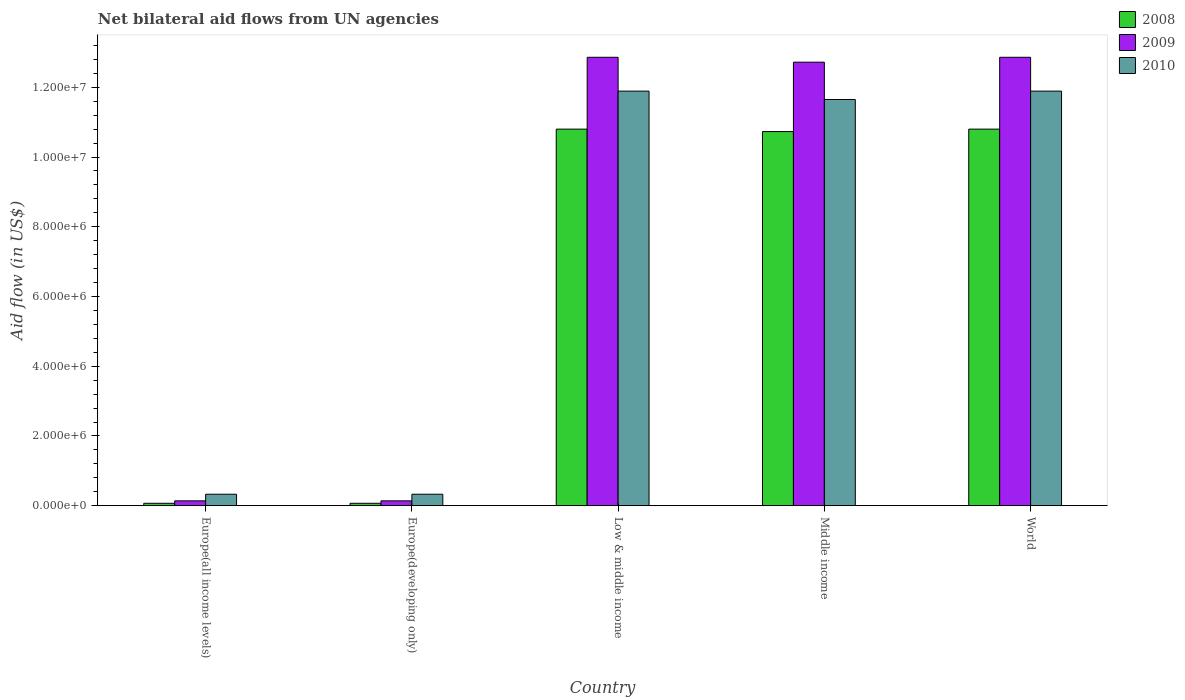How many different coloured bars are there?
Offer a terse response. 3. Are the number of bars per tick equal to the number of legend labels?
Your answer should be very brief. Yes. Are the number of bars on each tick of the X-axis equal?
Provide a short and direct response. Yes. How many bars are there on the 4th tick from the right?
Give a very brief answer. 3. What is the label of the 4th group of bars from the left?
Offer a terse response. Middle income. In how many cases, is the number of bars for a given country not equal to the number of legend labels?
Ensure brevity in your answer.  0. What is the net bilateral aid flow in 2009 in Middle income?
Ensure brevity in your answer.  1.27e+07. Across all countries, what is the maximum net bilateral aid flow in 2008?
Provide a short and direct response. 1.08e+07. Across all countries, what is the minimum net bilateral aid flow in 2008?
Your response must be concise. 7.00e+04. In which country was the net bilateral aid flow in 2008 maximum?
Make the answer very short. Low & middle income. In which country was the net bilateral aid flow in 2009 minimum?
Ensure brevity in your answer.  Europe(all income levels). What is the total net bilateral aid flow in 2009 in the graph?
Ensure brevity in your answer.  3.87e+07. What is the difference between the net bilateral aid flow in 2010 in Europe(all income levels) and that in World?
Provide a succinct answer. -1.16e+07. What is the difference between the net bilateral aid flow in 2008 in Europe(all income levels) and the net bilateral aid flow in 2010 in Low & middle income?
Your answer should be very brief. -1.18e+07. What is the average net bilateral aid flow in 2010 per country?
Ensure brevity in your answer.  7.22e+06. What is the difference between the net bilateral aid flow of/in 2009 and net bilateral aid flow of/in 2010 in Middle income?
Your answer should be very brief. 1.07e+06. In how many countries, is the net bilateral aid flow in 2008 greater than 400000 US$?
Give a very brief answer. 3. What is the ratio of the net bilateral aid flow in 2008 in Low & middle income to that in Middle income?
Make the answer very short. 1.01. Is the net bilateral aid flow in 2009 in Europe(all income levels) less than that in Low & middle income?
Give a very brief answer. Yes. Is the difference between the net bilateral aid flow in 2009 in Europe(developing only) and World greater than the difference between the net bilateral aid flow in 2010 in Europe(developing only) and World?
Keep it short and to the point. No. What is the difference between the highest and the second highest net bilateral aid flow in 2010?
Provide a short and direct response. 2.40e+05. What is the difference between the highest and the lowest net bilateral aid flow in 2010?
Make the answer very short. 1.16e+07. What does the 2nd bar from the left in World represents?
Offer a terse response. 2009. Is it the case that in every country, the sum of the net bilateral aid flow in 2010 and net bilateral aid flow in 2008 is greater than the net bilateral aid flow in 2009?
Your response must be concise. Yes. How many bars are there?
Your response must be concise. 15. How many countries are there in the graph?
Make the answer very short. 5. What is the difference between two consecutive major ticks on the Y-axis?
Provide a short and direct response. 2.00e+06. Are the values on the major ticks of Y-axis written in scientific E-notation?
Your answer should be compact. Yes. How many legend labels are there?
Provide a succinct answer. 3. How are the legend labels stacked?
Ensure brevity in your answer.  Vertical. What is the title of the graph?
Make the answer very short. Net bilateral aid flows from UN agencies. Does "1996" appear as one of the legend labels in the graph?
Keep it short and to the point. No. What is the label or title of the X-axis?
Provide a short and direct response. Country. What is the label or title of the Y-axis?
Your answer should be very brief. Aid flow (in US$). What is the Aid flow (in US$) of 2008 in Europe(all income levels)?
Provide a succinct answer. 7.00e+04. What is the Aid flow (in US$) in 2010 in Europe(all income levels)?
Give a very brief answer. 3.30e+05. What is the Aid flow (in US$) in 2008 in Low & middle income?
Provide a short and direct response. 1.08e+07. What is the Aid flow (in US$) in 2009 in Low & middle income?
Your response must be concise. 1.29e+07. What is the Aid flow (in US$) in 2010 in Low & middle income?
Keep it short and to the point. 1.19e+07. What is the Aid flow (in US$) in 2008 in Middle income?
Provide a short and direct response. 1.07e+07. What is the Aid flow (in US$) of 2009 in Middle income?
Provide a short and direct response. 1.27e+07. What is the Aid flow (in US$) in 2010 in Middle income?
Give a very brief answer. 1.16e+07. What is the Aid flow (in US$) in 2008 in World?
Offer a very short reply. 1.08e+07. What is the Aid flow (in US$) of 2009 in World?
Offer a terse response. 1.29e+07. What is the Aid flow (in US$) of 2010 in World?
Your response must be concise. 1.19e+07. Across all countries, what is the maximum Aid flow (in US$) in 2008?
Provide a succinct answer. 1.08e+07. Across all countries, what is the maximum Aid flow (in US$) of 2009?
Keep it short and to the point. 1.29e+07. Across all countries, what is the maximum Aid flow (in US$) of 2010?
Ensure brevity in your answer.  1.19e+07. Across all countries, what is the minimum Aid flow (in US$) in 2008?
Offer a terse response. 7.00e+04. Across all countries, what is the minimum Aid flow (in US$) of 2009?
Keep it short and to the point. 1.40e+05. What is the total Aid flow (in US$) in 2008 in the graph?
Your answer should be very brief. 3.25e+07. What is the total Aid flow (in US$) in 2009 in the graph?
Make the answer very short. 3.87e+07. What is the total Aid flow (in US$) in 2010 in the graph?
Ensure brevity in your answer.  3.61e+07. What is the difference between the Aid flow (in US$) in 2008 in Europe(all income levels) and that in Low & middle income?
Make the answer very short. -1.07e+07. What is the difference between the Aid flow (in US$) in 2009 in Europe(all income levels) and that in Low & middle income?
Provide a short and direct response. -1.27e+07. What is the difference between the Aid flow (in US$) of 2010 in Europe(all income levels) and that in Low & middle income?
Make the answer very short. -1.16e+07. What is the difference between the Aid flow (in US$) in 2008 in Europe(all income levels) and that in Middle income?
Keep it short and to the point. -1.07e+07. What is the difference between the Aid flow (in US$) of 2009 in Europe(all income levels) and that in Middle income?
Your answer should be very brief. -1.26e+07. What is the difference between the Aid flow (in US$) in 2010 in Europe(all income levels) and that in Middle income?
Your answer should be compact. -1.13e+07. What is the difference between the Aid flow (in US$) of 2008 in Europe(all income levels) and that in World?
Your answer should be compact. -1.07e+07. What is the difference between the Aid flow (in US$) in 2009 in Europe(all income levels) and that in World?
Your response must be concise. -1.27e+07. What is the difference between the Aid flow (in US$) in 2010 in Europe(all income levels) and that in World?
Offer a very short reply. -1.16e+07. What is the difference between the Aid flow (in US$) of 2008 in Europe(developing only) and that in Low & middle income?
Your response must be concise. -1.07e+07. What is the difference between the Aid flow (in US$) of 2009 in Europe(developing only) and that in Low & middle income?
Give a very brief answer. -1.27e+07. What is the difference between the Aid flow (in US$) in 2010 in Europe(developing only) and that in Low & middle income?
Ensure brevity in your answer.  -1.16e+07. What is the difference between the Aid flow (in US$) in 2008 in Europe(developing only) and that in Middle income?
Your answer should be compact. -1.07e+07. What is the difference between the Aid flow (in US$) in 2009 in Europe(developing only) and that in Middle income?
Your answer should be compact. -1.26e+07. What is the difference between the Aid flow (in US$) of 2010 in Europe(developing only) and that in Middle income?
Give a very brief answer. -1.13e+07. What is the difference between the Aid flow (in US$) in 2008 in Europe(developing only) and that in World?
Your answer should be very brief. -1.07e+07. What is the difference between the Aid flow (in US$) in 2009 in Europe(developing only) and that in World?
Your answer should be compact. -1.27e+07. What is the difference between the Aid flow (in US$) in 2010 in Europe(developing only) and that in World?
Keep it short and to the point. -1.16e+07. What is the difference between the Aid flow (in US$) of 2008 in Low & middle income and that in World?
Your response must be concise. 0. What is the difference between the Aid flow (in US$) in 2010 in Low & middle income and that in World?
Provide a succinct answer. 0. What is the difference between the Aid flow (in US$) of 2009 in Middle income and that in World?
Your response must be concise. -1.40e+05. What is the difference between the Aid flow (in US$) in 2009 in Europe(all income levels) and the Aid flow (in US$) in 2010 in Europe(developing only)?
Offer a very short reply. -1.90e+05. What is the difference between the Aid flow (in US$) in 2008 in Europe(all income levels) and the Aid flow (in US$) in 2009 in Low & middle income?
Make the answer very short. -1.28e+07. What is the difference between the Aid flow (in US$) of 2008 in Europe(all income levels) and the Aid flow (in US$) of 2010 in Low & middle income?
Your answer should be compact. -1.18e+07. What is the difference between the Aid flow (in US$) in 2009 in Europe(all income levels) and the Aid flow (in US$) in 2010 in Low & middle income?
Provide a short and direct response. -1.18e+07. What is the difference between the Aid flow (in US$) in 2008 in Europe(all income levels) and the Aid flow (in US$) in 2009 in Middle income?
Offer a very short reply. -1.26e+07. What is the difference between the Aid flow (in US$) of 2008 in Europe(all income levels) and the Aid flow (in US$) of 2010 in Middle income?
Provide a succinct answer. -1.16e+07. What is the difference between the Aid flow (in US$) in 2009 in Europe(all income levels) and the Aid flow (in US$) in 2010 in Middle income?
Ensure brevity in your answer.  -1.15e+07. What is the difference between the Aid flow (in US$) in 2008 in Europe(all income levels) and the Aid flow (in US$) in 2009 in World?
Provide a succinct answer. -1.28e+07. What is the difference between the Aid flow (in US$) in 2008 in Europe(all income levels) and the Aid flow (in US$) in 2010 in World?
Provide a succinct answer. -1.18e+07. What is the difference between the Aid flow (in US$) of 2009 in Europe(all income levels) and the Aid flow (in US$) of 2010 in World?
Your response must be concise. -1.18e+07. What is the difference between the Aid flow (in US$) of 2008 in Europe(developing only) and the Aid flow (in US$) of 2009 in Low & middle income?
Give a very brief answer. -1.28e+07. What is the difference between the Aid flow (in US$) of 2008 in Europe(developing only) and the Aid flow (in US$) of 2010 in Low & middle income?
Your answer should be compact. -1.18e+07. What is the difference between the Aid flow (in US$) of 2009 in Europe(developing only) and the Aid flow (in US$) of 2010 in Low & middle income?
Provide a succinct answer. -1.18e+07. What is the difference between the Aid flow (in US$) in 2008 in Europe(developing only) and the Aid flow (in US$) in 2009 in Middle income?
Ensure brevity in your answer.  -1.26e+07. What is the difference between the Aid flow (in US$) of 2008 in Europe(developing only) and the Aid flow (in US$) of 2010 in Middle income?
Offer a terse response. -1.16e+07. What is the difference between the Aid flow (in US$) of 2009 in Europe(developing only) and the Aid flow (in US$) of 2010 in Middle income?
Make the answer very short. -1.15e+07. What is the difference between the Aid flow (in US$) of 2008 in Europe(developing only) and the Aid flow (in US$) of 2009 in World?
Your response must be concise. -1.28e+07. What is the difference between the Aid flow (in US$) of 2008 in Europe(developing only) and the Aid flow (in US$) of 2010 in World?
Offer a terse response. -1.18e+07. What is the difference between the Aid flow (in US$) in 2009 in Europe(developing only) and the Aid flow (in US$) in 2010 in World?
Your response must be concise. -1.18e+07. What is the difference between the Aid flow (in US$) of 2008 in Low & middle income and the Aid flow (in US$) of 2009 in Middle income?
Your response must be concise. -1.92e+06. What is the difference between the Aid flow (in US$) in 2008 in Low & middle income and the Aid flow (in US$) in 2010 in Middle income?
Ensure brevity in your answer.  -8.50e+05. What is the difference between the Aid flow (in US$) in 2009 in Low & middle income and the Aid flow (in US$) in 2010 in Middle income?
Offer a terse response. 1.21e+06. What is the difference between the Aid flow (in US$) of 2008 in Low & middle income and the Aid flow (in US$) of 2009 in World?
Offer a very short reply. -2.06e+06. What is the difference between the Aid flow (in US$) of 2008 in Low & middle income and the Aid flow (in US$) of 2010 in World?
Your answer should be compact. -1.09e+06. What is the difference between the Aid flow (in US$) in 2009 in Low & middle income and the Aid flow (in US$) in 2010 in World?
Give a very brief answer. 9.70e+05. What is the difference between the Aid flow (in US$) of 2008 in Middle income and the Aid flow (in US$) of 2009 in World?
Your answer should be very brief. -2.13e+06. What is the difference between the Aid flow (in US$) in 2008 in Middle income and the Aid flow (in US$) in 2010 in World?
Your response must be concise. -1.16e+06. What is the difference between the Aid flow (in US$) of 2009 in Middle income and the Aid flow (in US$) of 2010 in World?
Ensure brevity in your answer.  8.30e+05. What is the average Aid flow (in US$) of 2008 per country?
Offer a terse response. 6.49e+06. What is the average Aid flow (in US$) of 2009 per country?
Offer a very short reply. 7.74e+06. What is the average Aid flow (in US$) of 2010 per country?
Provide a short and direct response. 7.22e+06. What is the difference between the Aid flow (in US$) of 2008 and Aid flow (in US$) of 2009 in Europe(all income levels)?
Give a very brief answer. -7.00e+04. What is the difference between the Aid flow (in US$) in 2008 and Aid flow (in US$) in 2010 in Europe(developing only)?
Make the answer very short. -2.60e+05. What is the difference between the Aid flow (in US$) in 2008 and Aid flow (in US$) in 2009 in Low & middle income?
Offer a terse response. -2.06e+06. What is the difference between the Aid flow (in US$) of 2008 and Aid flow (in US$) of 2010 in Low & middle income?
Keep it short and to the point. -1.09e+06. What is the difference between the Aid flow (in US$) in 2009 and Aid flow (in US$) in 2010 in Low & middle income?
Offer a very short reply. 9.70e+05. What is the difference between the Aid flow (in US$) of 2008 and Aid flow (in US$) of 2009 in Middle income?
Provide a short and direct response. -1.99e+06. What is the difference between the Aid flow (in US$) of 2008 and Aid flow (in US$) of 2010 in Middle income?
Ensure brevity in your answer.  -9.20e+05. What is the difference between the Aid flow (in US$) of 2009 and Aid flow (in US$) of 2010 in Middle income?
Ensure brevity in your answer.  1.07e+06. What is the difference between the Aid flow (in US$) of 2008 and Aid flow (in US$) of 2009 in World?
Offer a terse response. -2.06e+06. What is the difference between the Aid flow (in US$) of 2008 and Aid flow (in US$) of 2010 in World?
Offer a very short reply. -1.09e+06. What is the difference between the Aid flow (in US$) of 2009 and Aid flow (in US$) of 2010 in World?
Ensure brevity in your answer.  9.70e+05. What is the ratio of the Aid flow (in US$) of 2008 in Europe(all income levels) to that in Europe(developing only)?
Your response must be concise. 1. What is the ratio of the Aid flow (in US$) of 2009 in Europe(all income levels) to that in Europe(developing only)?
Offer a terse response. 1. What is the ratio of the Aid flow (in US$) in 2010 in Europe(all income levels) to that in Europe(developing only)?
Your answer should be very brief. 1. What is the ratio of the Aid flow (in US$) in 2008 in Europe(all income levels) to that in Low & middle income?
Offer a very short reply. 0.01. What is the ratio of the Aid flow (in US$) in 2009 in Europe(all income levels) to that in Low & middle income?
Provide a succinct answer. 0.01. What is the ratio of the Aid flow (in US$) in 2010 in Europe(all income levels) to that in Low & middle income?
Offer a terse response. 0.03. What is the ratio of the Aid flow (in US$) of 2008 in Europe(all income levels) to that in Middle income?
Keep it short and to the point. 0.01. What is the ratio of the Aid flow (in US$) in 2009 in Europe(all income levels) to that in Middle income?
Offer a terse response. 0.01. What is the ratio of the Aid flow (in US$) of 2010 in Europe(all income levels) to that in Middle income?
Offer a terse response. 0.03. What is the ratio of the Aid flow (in US$) in 2008 in Europe(all income levels) to that in World?
Your response must be concise. 0.01. What is the ratio of the Aid flow (in US$) of 2009 in Europe(all income levels) to that in World?
Your answer should be very brief. 0.01. What is the ratio of the Aid flow (in US$) in 2010 in Europe(all income levels) to that in World?
Your answer should be very brief. 0.03. What is the ratio of the Aid flow (in US$) in 2008 in Europe(developing only) to that in Low & middle income?
Make the answer very short. 0.01. What is the ratio of the Aid flow (in US$) of 2009 in Europe(developing only) to that in Low & middle income?
Offer a very short reply. 0.01. What is the ratio of the Aid flow (in US$) in 2010 in Europe(developing only) to that in Low & middle income?
Offer a very short reply. 0.03. What is the ratio of the Aid flow (in US$) of 2008 in Europe(developing only) to that in Middle income?
Provide a succinct answer. 0.01. What is the ratio of the Aid flow (in US$) of 2009 in Europe(developing only) to that in Middle income?
Offer a terse response. 0.01. What is the ratio of the Aid flow (in US$) in 2010 in Europe(developing only) to that in Middle income?
Offer a terse response. 0.03. What is the ratio of the Aid flow (in US$) in 2008 in Europe(developing only) to that in World?
Offer a terse response. 0.01. What is the ratio of the Aid flow (in US$) in 2009 in Europe(developing only) to that in World?
Your answer should be very brief. 0.01. What is the ratio of the Aid flow (in US$) in 2010 in Europe(developing only) to that in World?
Make the answer very short. 0.03. What is the ratio of the Aid flow (in US$) in 2008 in Low & middle income to that in Middle income?
Your answer should be very brief. 1.01. What is the ratio of the Aid flow (in US$) in 2010 in Low & middle income to that in Middle income?
Your response must be concise. 1.02. What is the ratio of the Aid flow (in US$) in 2008 in Low & middle income to that in World?
Make the answer very short. 1. What is the ratio of the Aid flow (in US$) of 2010 in Low & middle income to that in World?
Make the answer very short. 1. What is the ratio of the Aid flow (in US$) of 2008 in Middle income to that in World?
Offer a very short reply. 0.99. What is the ratio of the Aid flow (in US$) in 2010 in Middle income to that in World?
Give a very brief answer. 0.98. What is the difference between the highest and the lowest Aid flow (in US$) in 2008?
Make the answer very short. 1.07e+07. What is the difference between the highest and the lowest Aid flow (in US$) of 2009?
Provide a succinct answer. 1.27e+07. What is the difference between the highest and the lowest Aid flow (in US$) of 2010?
Ensure brevity in your answer.  1.16e+07. 